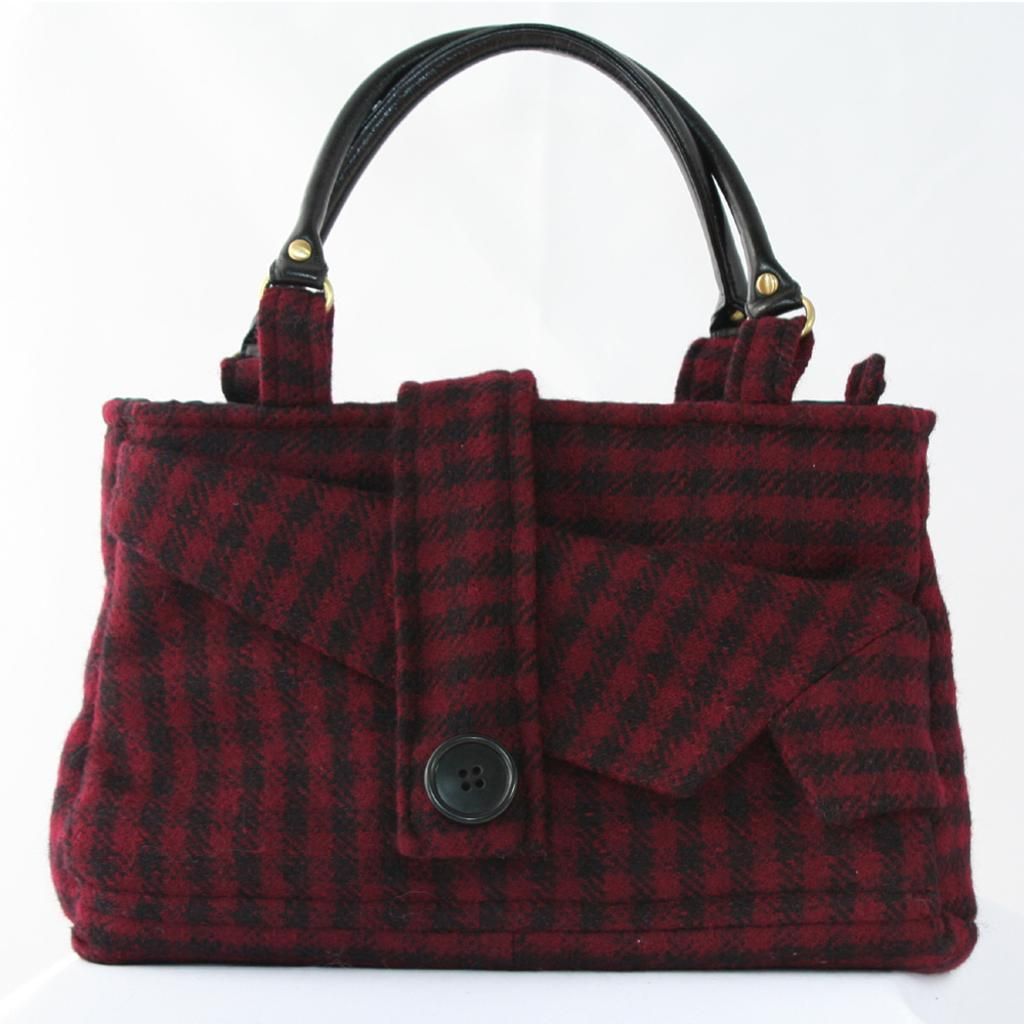What object is present in the image that can be used for carrying items? There is a bag in the image that can be used for carrying items. What colors are featured on the bag in the image? The bag has red and black colors. What part of the bag is black? The bag has a black handle and a black button. What type of calendar is displayed on the bag in the image? There is no calendar present on the bag in the image. How does the bag showcase the latest fashion trends? The provided facts do not mention any fashion trends related to the bag. 